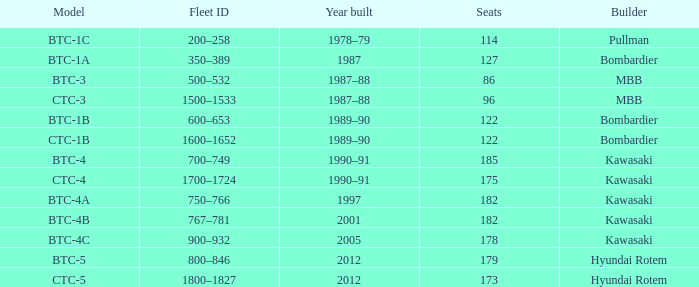Which model has 175 seats? CTC-4. 